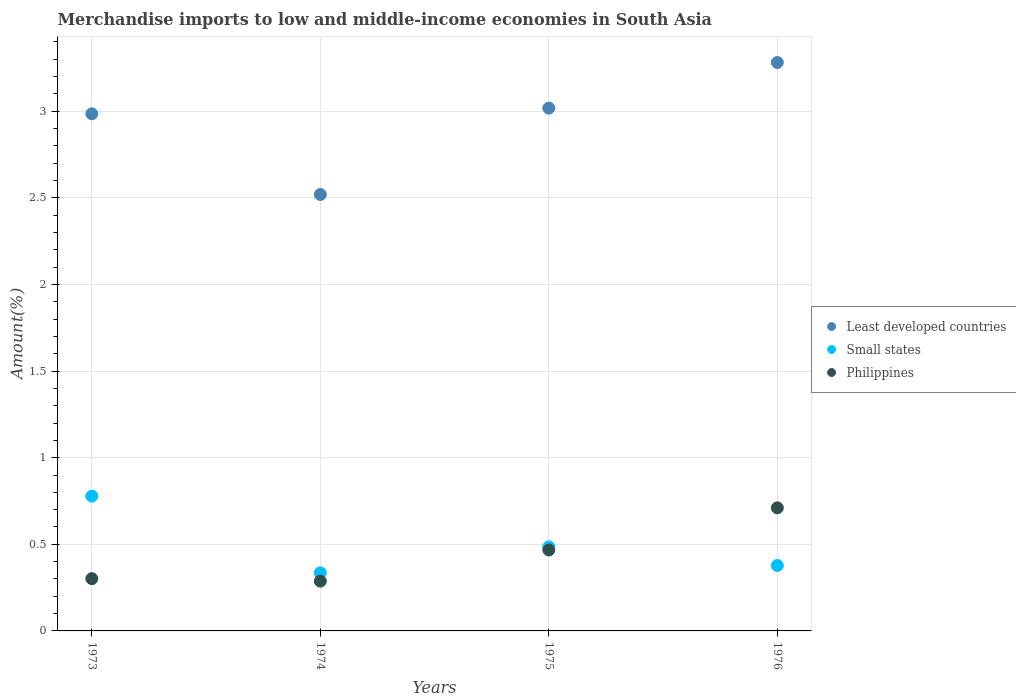How many different coloured dotlines are there?
Your answer should be very brief. 3. What is the percentage of amount earned from merchandise imports in Least developed countries in 1976?
Provide a short and direct response. 3.28. Across all years, what is the maximum percentage of amount earned from merchandise imports in Philippines?
Ensure brevity in your answer.  0.71. Across all years, what is the minimum percentage of amount earned from merchandise imports in Small states?
Offer a terse response. 0.34. In which year was the percentage of amount earned from merchandise imports in Philippines maximum?
Your answer should be compact. 1976. In which year was the percentage of amount earned from merchandise imports in Small states minimum?
Make the answer very short. 1974. What is the total percentage of amount earned from merchandise imports in Least developed countries in the graph?
Ensure brevity in your answer.  11.8. What is the difference between the percentage of amount earned from merchandise imports in Least developed countries in 1973 and that in 1975?
Give a very brief answer. -0.03. What is the difference between the percentage of amount earned from merchandise imports in Philippines in 1973 and the percentage of amount earned from merchandise imports in Least developed countries in 1976?
Your answer should be compact. -2.98. What is the average percentage of amount earned from merchandise imports in Small states per year?
Your response must be concise. 0.49. In the year 1975, what is the difference between the percentage of amount earned from merchandise imports in Small states and percentage of amount earned from merchandise imports in Philippines?
Your answer should be compact. 0.02. In how many years, is the percentage of amount earned from merchandise imports in Philippines greater than 0.6 %?
Keep it short and to the point. 1. What is the ratio of the percentage of amount earned from merchandise imports in Philippines in 1974 to that in 1976?
Provide a succinct answer. 0.4. Is the percentage of amount earned from merchandise imports in Philippines in 1973 less than that in 1974?
Ensure brevity in your answer.  No. What is the difference between the highest and the second highest percentage of amount earned from merchandise imports in Small states?
Your response must be concise. 0.29. What is the difference between the highest and the lowest percentage of amount earned from merchandise imports in Least developed countries?
Offer a terse response. 0.76. In how many years, is the percentage of amount earned from merchandise imports in Least developed countries greater than the average percentage of amount earned from merchandise imports in Least developed countries taken over all years?
Your answer should be very brief. 3. Is the sum of the percentage of amount earned from merchandise imports in Philippines in 1973 and 1975 greater than the maximum percentage of amount earned from merchandise imports in Small states across all years?
Make the answer very short. No. Is it the case that in every year, the sum of the percentage of amount earned from merchandise imports in Philippines and percentage of amount earned from merchandise imports in Least developed countries  is greater than the percentage of amount earned from merchandise imports in Small states?
Provide a short and direct response. Yes. How many dotlines are there?
Give a very brief answer. 3. Does the graph contain any zero values?
Your response must be concise. No. Does the graph contain grids?
Offer a very short reply. Yes. Where does the legend appear in the graph?
Keep it short and to the point. Center right. What is the title of the graph?
Your answer should be compact. Merchandise imports to low and middle-income economies in South Asia. Does "Solomon Islands" appear as one of the legend labels in the graph?
Keep it short and to the point. No. What is the label or title of the X-axis?
Give a very brief answer. Years. What is the label or title of the Y-axis?
Your answer should be compact. Amount(%). What is the Amount(%) of Least developed countries in 1973?
Ensure brevity in your answer.  2.99. What is the Amount(%) in Small states in 1973?
Your answer should be compact. 0.78. What is the Amount(%) of Philippines in 1973?
Your response must be concise. 0.3. What is the Amount(%) of Least developed countries in 1974?
Make the answer very short. 2.52. What is the Amount(%) of Small states in 1974?
Provide a short and direct response. 0.34. What is the Amount(%) in Philippines in 1974?
Provide a short and direct response. 0.29. What is the Amount(%) of Least developed countries in 1975?
Offer a very short reply. 3.02. What is the Amount(%) in Small states in 1975?
Offer a very short reply. 0.49. What is the Amount(%) in Philippines in 1975?
Your response must be concise. 0.47. What is the Amount(%) of Least developed countries in 1976?
Ensure brevity in your answer.  3.28. What is the Amount(%) in Small states in 1976?
Your answer should be very brief. 0.38. What is the Amount(%) in Philippines in 1976?
Your answer should be compact. 0.71. Across all years, what is the maximum Amount(%) in Least developed countries?
Ensure brevity in your answer.  3.28. Across all years, what is the maximum Amount(%) in Small states?
Provide a short and direct response. 0.78. Across all years, what is the maximum Amount(%) of Philippines?
Provide a short and direct response. 0.71. Across all years, what is the minimum Amount(%) of Least developed countries?
Keep it short and to the point. 2.52. Across all years, what is the minimum Amount(%) in Small states?
Ensure brevity in your answer.  0.34. Across all years, what is the minimum Amount(%) in Philippines?
Give a very brief answer. 0.29. What is the total Amount(%) in Least developed countries in the graph?
Offer a terse response. 11.8. What is the total Amount(%) in Small states in the graph?
Your response must be concise. 1.98. What is the total Amount(%) in Philippines in the graph?
Give a very brief answer. 1.77. What is the difference between the Amount(%) in Least developed countries in 1973 and that in 1974?
Ensure brevity in your answer.  0.47. What is the difference between the Amount(%) in Small states in 1973 and that in 1974?
Ensure brevity in your answer.  0.44. What is the difference between the Amount(%) of Philippines in 1973 and that in 1974?
Offer a terse response. 0.01. What is the difference between the Amount(%) in Least developed countries in 1973 and that in 1975?
Your answer should be very brief. -0.03. What is the difference between the Amount(%) of Small states in 1973 and that in 1975?
Provide a succinct answer. 0.29. What is the difference between the Amount(%) in Philippines in 1973 and that in 1975?
Offer a terse response. -0.17. What is the difference between the Amount(%) of Least developed countries in 1973 and that in 1976?
Offer a very short reply. -0.3. What is the difference between the Amount(%) of Small states in 1973 and that in 1976?
Provide a short and direct response. 0.4. What is the difference between the Amount(%) in Philippines in 1973 and that in 1976?
Your answer should be compact. -0.41. What is the difference between the Amount(%) in Least developed countries in 1974 and that in 1975?
Your answer should be very brief. -0.5. What is the difference between the Amount(%) of Small states in 1974 and that in 1975?
Your answer should be compact. -0.15. What is the difference between the Amount(%) of Philippines in 1974 and that in 1975?
Offer a terse response. -0.18. What is the difference between the Amount(%) of Least developed countries in 1974 and that in 1976?
Provide a short and direct response. -0.76. What is the difference between the Amount(%) in Small states in 1974 and that in 1976?
Your answer should be compact. -0.04. What is the difference between the Amount(%) in Philippines in 1974 and that in 1976?
Offer a terse response. -0.42. What is the difference between the Amount(%) in Least developed countries in 1975 and that in 1976?
Offer a terse response. -0.26. What is the difference between the Amount(%) in Small states in 1975 and that in 1976?
Offer a very short reply. 0.11. What is the difference between the Amount(%) of Philippines in 1975 and that in 1976?
Make the answer very short. -0.24. What is the difference between the Amount(%) in Least developed countries in 1973 and the Amount(%) in Small states in 1974?
Provide a succinct answer. 2.65. What is the difference between the Amount(%) in Least developed countries in 1973 and the Amount(%) in Philippines in 1974?
Provide a succinct answer. 2.7. What is the difference between the Amount(%) in Small states in 1973 and the Amount(%) in Philippines in 1974?
Ensure brevity in your answer.  0.49. What is the difference between the Amount(%) in Least developed countries in 1973 and the Amount(%) in Small states in 1975?
Your answer should be very brief. 2.5. What is the difference between the Amount(%) of Least developed countries in 1973 and the Amount(%) of Philippines in 1975?
Keep it short and to the point. 2.52. What is the difference between the Amount(%) in Small states in 1973 and the Amount(%) in Philippines in 1975?
Ensure brevity in your answer.  0.31. What is the difference between the Amount(%) of Least developed countries in 1973 and the Amount(%) of Small states in 1976?
Your response must be concise. 2.61. What is the difference between the Amount(%) of Least developed countries in 1973 and the Amount(%) of Philippines in 1976?
Your response must be concise. 2.27. What is the difference between the Amount(%) in Small states in 1973 and the Amount(%) in Philippines in 1976?
Keep it short and to the point. 0.07. What is the difference between the Amount(%) in Least developed countries in 1974 and the Amount(%) in Small states in 1975?
Give a very brief answer. 2.03. What is the difference between the Amount(%) of Least developed countries in 1974 and the Amount(%) of Philippines in 1975?
Offer a very short reply. 2.05. What is the difference between the Amount(%) in Small states in 1974 and the Amount(%) in Philippines in 1975?
Your answer should be compact. -0.13. What is the difference between the Amount(%) of Least developed countries in 1974 and the Amount(%) of Small states in 1976?
Your answer should be very brief. 2.14. What is the difference between the Amount(%) in Least developed countries in 1974 and the Amount(%) in Philippines in 1976?
Your answer should be compact. 1.81. What is the difference between the Amount(%) in Small states in 1974 and the Amount(%) in Philippines in 1976?
Your answer should be very brief. -0.38. What is the difference between the Amount(%) in Least developed countries in 1975 and the Amount(%) in Small states in 1976?
Provide a succinct answer. 2.64. What is the difference between the Amount(%) in Least developed countries in 1975 and the Amount(%) in Philippines in 1976?
Provide a succinct answer. 2.31. What is the difference between the Amount(%) of Small states in 1975 and the Amount(%) of Philippines in 1976?
Your answer should be very brief. -0.23. What is the average Amount(%) in Least developed countries per year?
Give a very brief answer. 2.95. What is the average Amount(%) of Small states per year?
Give a very brief answer. 0.49. What is the average Amount(%) of Philippines per year?
Your answer should be very brief. 0.44. In the year 1973, what is the difference between the Amount(%) of Least developed countries and Amount(%) of Small states?
Provide a short and direct response. 2.21. In the year 1973, what is the difference between the Amount(%) in Least developed countries and Amount(%) in Philippines?
Your answer should be compact. 2.68. In the year 1973, what is the difference between the Amount(%) in Small states and Amount(%) in Philippines?
Make the answer very short. 0.48. In the year 1974, what is the difference between the Amount(%) in Least developed countries and Amount(%) in Small states?
Offer a very short reply. 2.18. In the year 1974, what is the difference between the Amount(%) of Least developed countries and Amount(%) of Philippines?
Offer a very short reply. 2.23. In the year 1974, what is the difference between the Amount(%) of Small states and Amount(%) of Philippines?
Keep it short and to the point. 0.05. In the year 1975, what is the difference between the Amount(%) in Least developed countries and Amount(%) in Small states?
Make the answer very short. 2.53. In the year 1975, what is the difference between the Amount(%) of Least developed countries and Amount(%) of Philippines?
Your answer should be compact. 2.55. In the year 1975, what is the difference between the Amount(%) in Small states and Amount(%) in Philippines?
Offer a terse response. 0.02. In the year 1976, what is the difference between the Amount(%) in Least developed countries and Amount(%) in Small states?
Keep it short and to the point. 2.9. In the year 1976, what is the difference between the Amount(%) of Least developed countries and Amount(%) of Philippines?
Make the answer very short. 2.57. In the year 1976, what is the difference between the Amount(%) in Small states and Amount(%) in Philippines?
Your answer should be very brief. -0.33. What is the ratio of the Amount(%) of Least developed countries in 1973 to that in 1974?
Your answer should be very brief. 1.18. What is the ratio of the Amount(%) of Small states in 1973 to that in 1974?
Your answer should be very brief. 2.32. What is the ratio of the Amount(%) in Philippines in 1973 to that in 1974?
Give a very brief answer. 1.05. What is the ratio of the Amount(%) in Least developed countries in 1973 to that in 1975?
Provide a short and direct response. 0.99. What is the ratio of the Amount(%) of Small states in 1973 to that in 1975?
Offer a terse response. 1.6. What is the ratio of the Amount(%) of Philippines in 1973 to that in 1975?
Offer a very short reply. 0.65. What is the ratio of the Amount(%) in Least developed countries in 1973 to that in 1976?
Offer a terse response. 0.91. What is the ratio of the Amount(%) in Small states in 1973 to that in 1976?
Your response must be concise. 2.06. What is the ratio of the Amount(%) in Philippines in 1973 to that in 1976?
Your answer should be compact. 0.42. What is the ratio of the Amount(%) of Least developed countries in 1974 to that in 1975?
Your answer should be very brief. 0.83. What is the ratio of the Amount(%) in Small states in 1974 to that in 1975?
Ensure brevity in your answer.  0.69. What is the ratio of the Amount(%) in Philippines in 1974 to that in 1975?
Provide a succinct answer. 0.62. What is the ratio of the Amount(%) of Least developed countries in 1974 to that in 1976?
Your answer should be compact. 0.77. What is the ratio of the Amount(%) in Small states in 1974 to that in 1976?
Ensure brevity in your answer.  0.89. What is the ratio of the Amount(%) in Philippines in 1974 to that in 1976?
Your answer should be very brief. 0.4. What is the ratio of the Amount(%) in Least developed countries in 1975 to that in 1976?
Provide a short and direct response. 0.92. What is the ratio of the Amount(%) in Small states in 1975 to that in 1976?
Offer a very short reply. 1.29. What is the ratio of the Amount(%) of Philippines in 1975 to that in 1976?
Keep it short and to the point. 0.66. What is the difference between the highest and the second highest Amount(%) in Least developed countries?
Provide a succinct answer. 0.26. What is the difference between the highest and the second highest Amount(%) of Small states?
Your response must be concise. 0.29. What is the difference between the highest and the second highest Amount(%) in Philippines?
Offer a terse response. 0.24. What is the difference between the highest and the lowest Amount(%) of Least developed countries?
Provide a short and direct response. 0.76. What is the difference between the highest and the lowest Amount(%) in Small states?
Provide a succinct answer. 0.44. What is the difference between the highest and the lowest Amount(%) in Philippines?
Your answer should be compact. 0.42. 